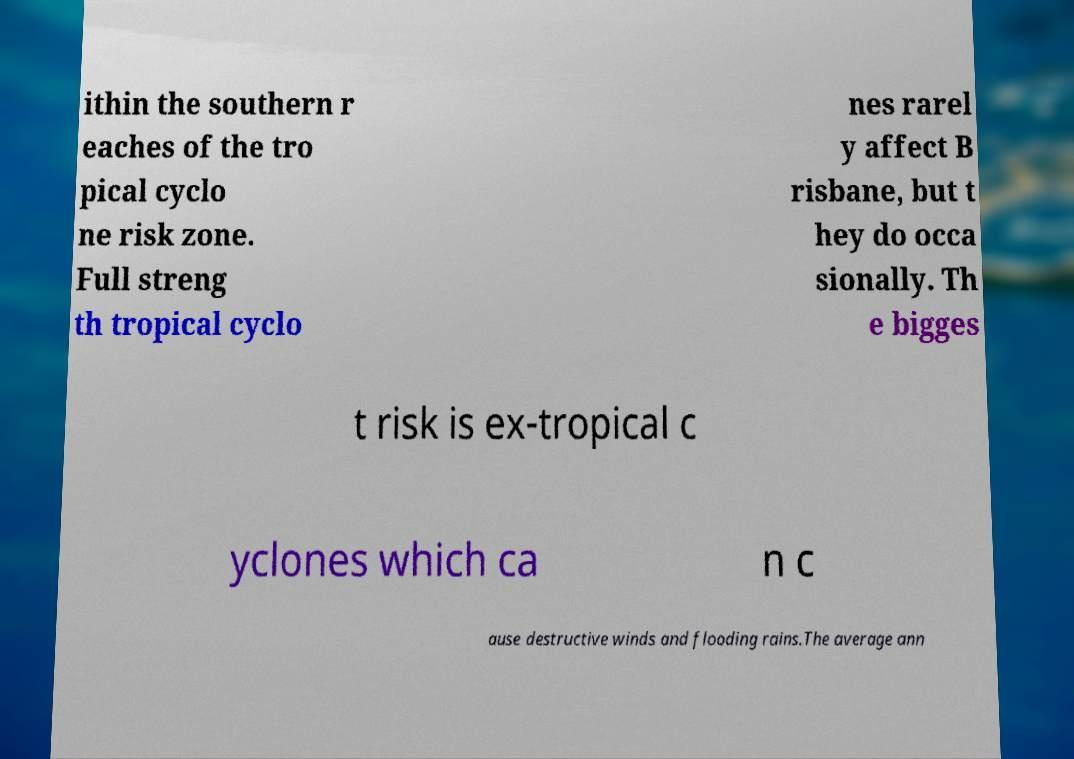Could you assist in decoding the text presented in this image and type it out clearly? ithin the southern r eaches of the tro pical cyclo ne risk zone. Full streng th tropical cyclo nes rarel y affect B risbane, but t hey do occa sionally. Th e bigges t risk is ex-tropical c yclones which ca n c ause destructive winds and flooding rains.The average ann 